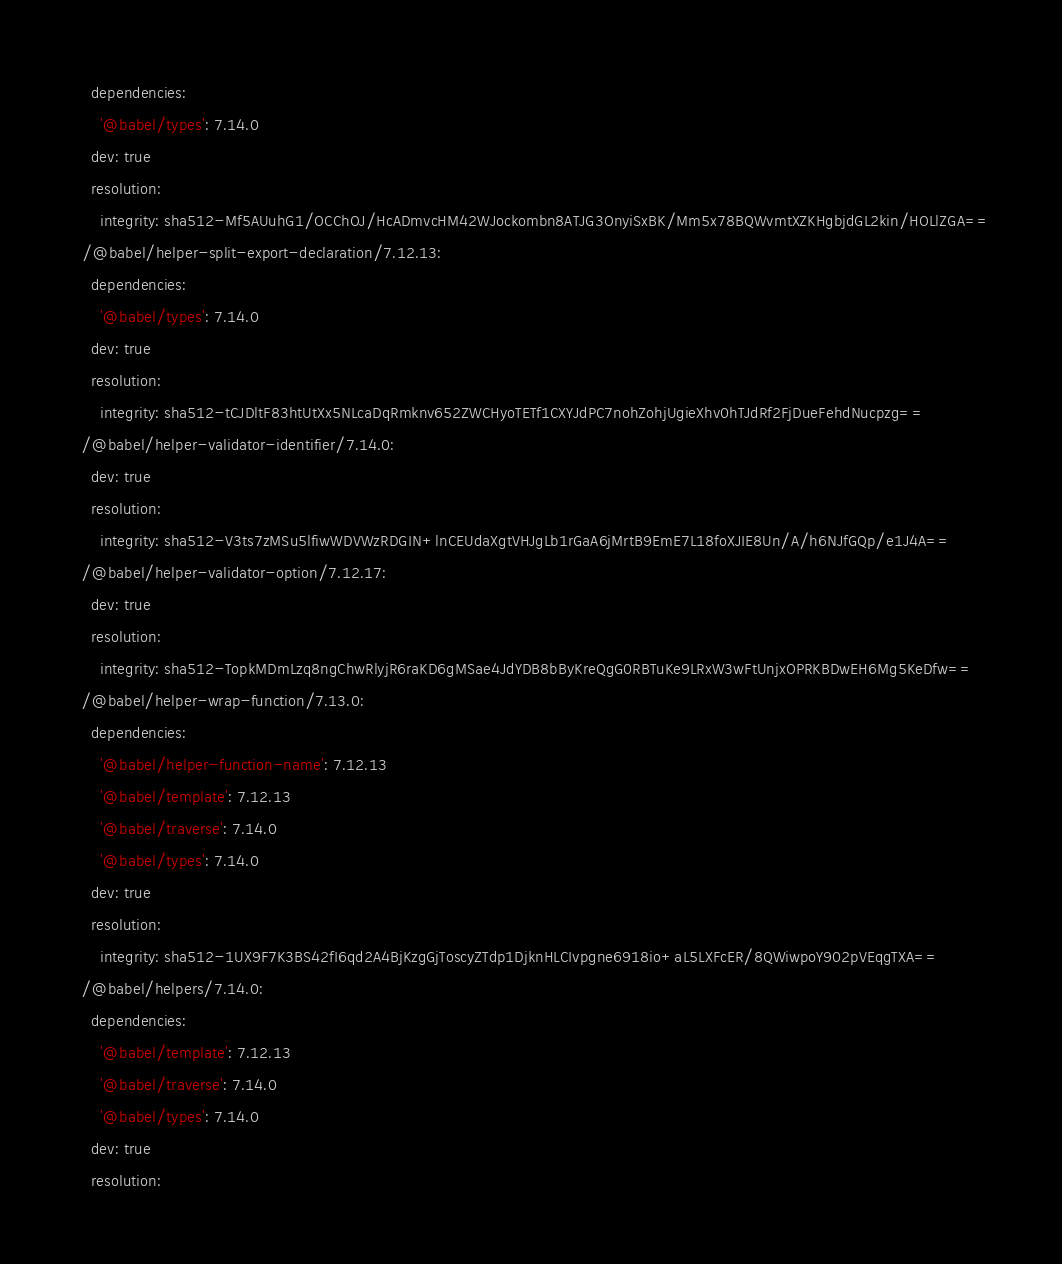<code> <loc_0><loc_0><loc_500><loc_500><_YAML_>    dependencies:
      '@babel/types': 7.14.0
    dev: true
    resolution:
      integrity: sha512-Mf5AUuhG1/OCChOJ/HcADmvcHM42WJockombn8ATJG3OnyiSxBK/Mm5x78BQWvmtXZKHgbjdGL2kin/HOLlZGA==
  /@babel/helper-split-export-declaration/7.12.13:
    dependencies:
      '@babel/types': 7.14.0
    dev: true
    resolution:
      integrity: sha512-tCJDltF83htUtXx5NLcaDqRmknv652ZWCHyoTETf1CXYJdPC7nohZohjUgieXhv0hTJdRf2FjDueFehdNucpzg==
  /@babel/helper-validator-identifier/7.14.0:
    dev: true
    resolution:
      integrity: sha512-V3ts7zMSu5lfiwWDVWzRDGIN+lnCEUdaXgtVHJgLb1rGaA6jMrtB9EmE7L18foXJIE8Un/A/h6NJfGQp/e1J4A==
  /@babel/helper-validator-option/7.12.17:
    dev: true
    resolution:
      integrity: sha512-TopkMDmLzq8ngChwRlyjR6raKD6gMSae4JdYDB8bByKreQgG0RBTuKe9LRxW3wFtUnjxOPRKBDwEH6Mg5KeDfw==
  /@babel/helper-wrap-function/7.13.0:
    dependencies:
      '@babel/helper-function-name': 7.12.13
      '@babel/template': 7.12.13
      '@babel/traverse': 7.14.0
      '@babel/types': 7.14.0
    dev: true
    resolution:
      integrity: sha512-1UX9F7K3BS42fI6qd2A4BjKzgGjToscyZTdp1DjknHLCIvpgne6918io+aL5LXFcER/8QWiwpoY902pVEqgTXA==
  /@babel/helpers/7.14.0:
    dependencies:
      '@babel/template': 7.12.13
      '@babel/traverse': 7.14.0
      '@babel/types': 7.14.0
    dev: true
    resolution:</code> 